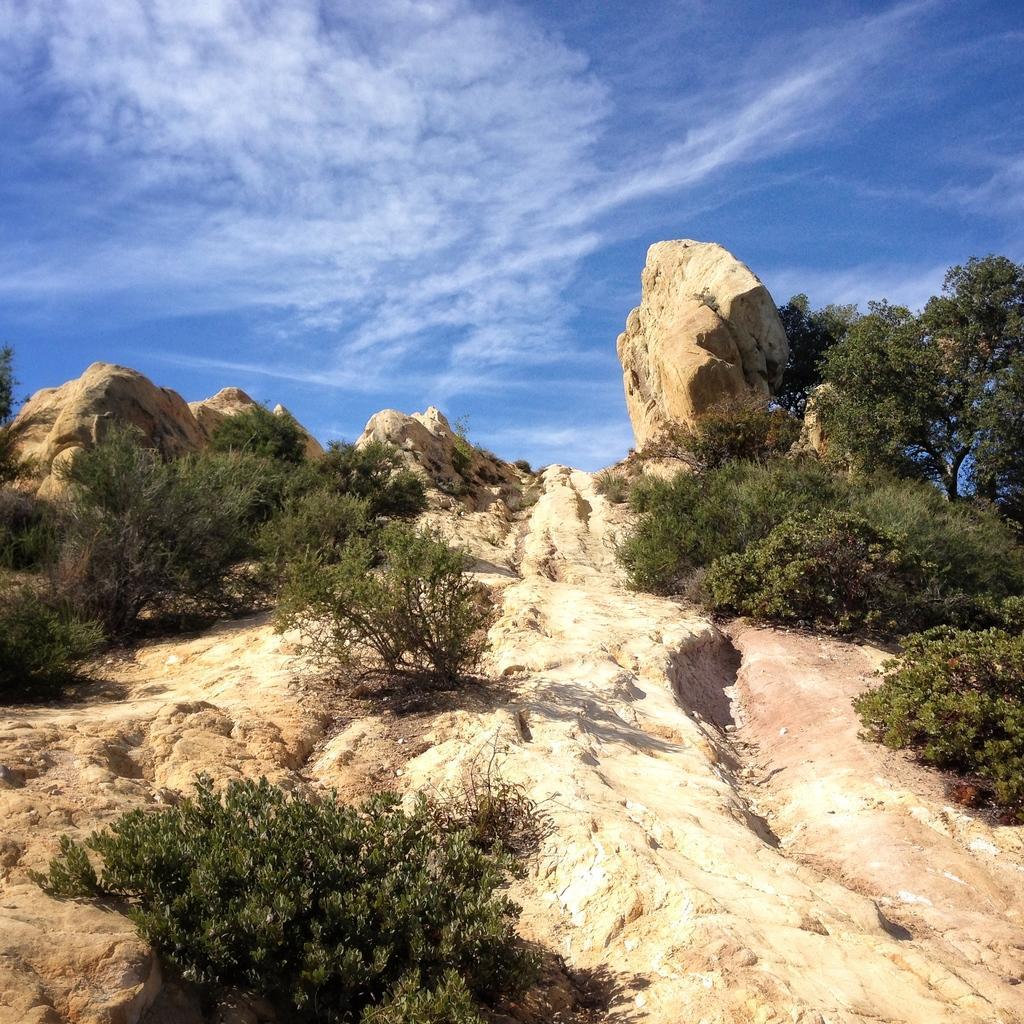Can you describe this image briefly? In this picture we can see stone mountain. On the bottom there is a plant. On the right we can see trees. On the top we can see sky and clouds. 